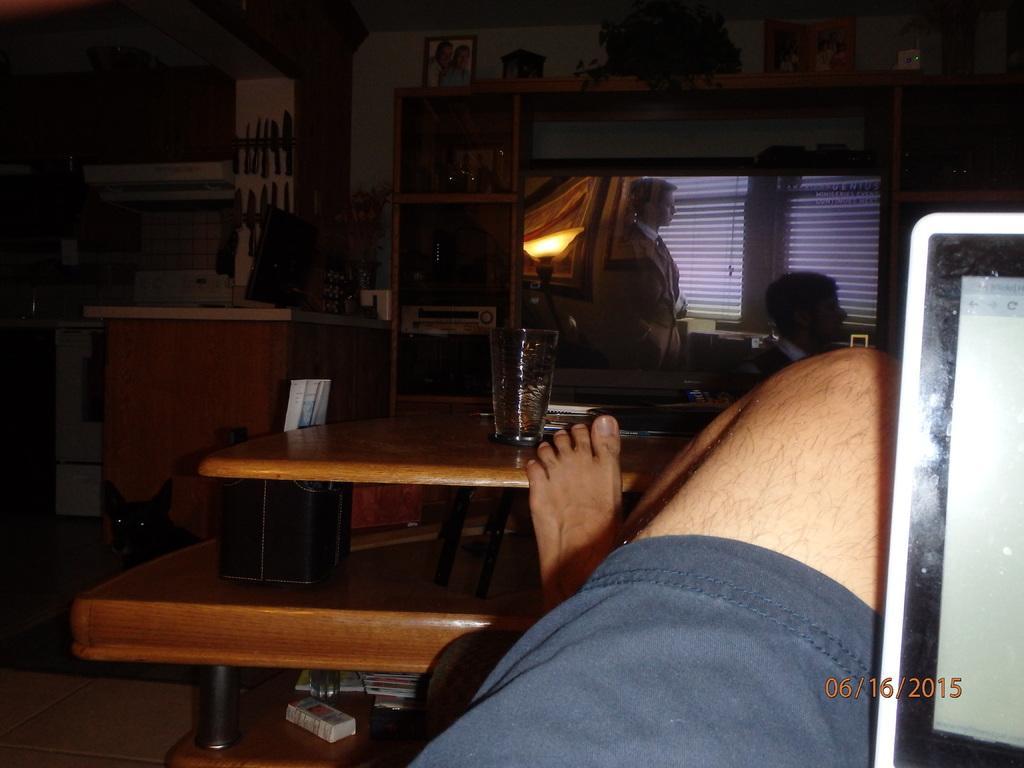In one or two sentences, can you explain what this image depicts? In this picture there is a boy, who is placing his leg on the table and there is a television at the center of the image and there is also a laptop at the right side of the image. 